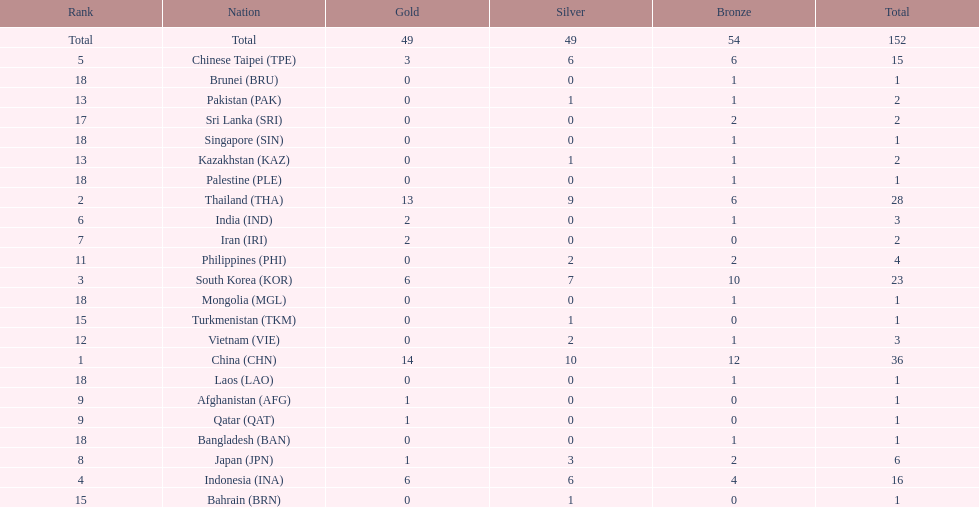Did the philippines or kazakhstan have a higher number of total medals? Philippines. 